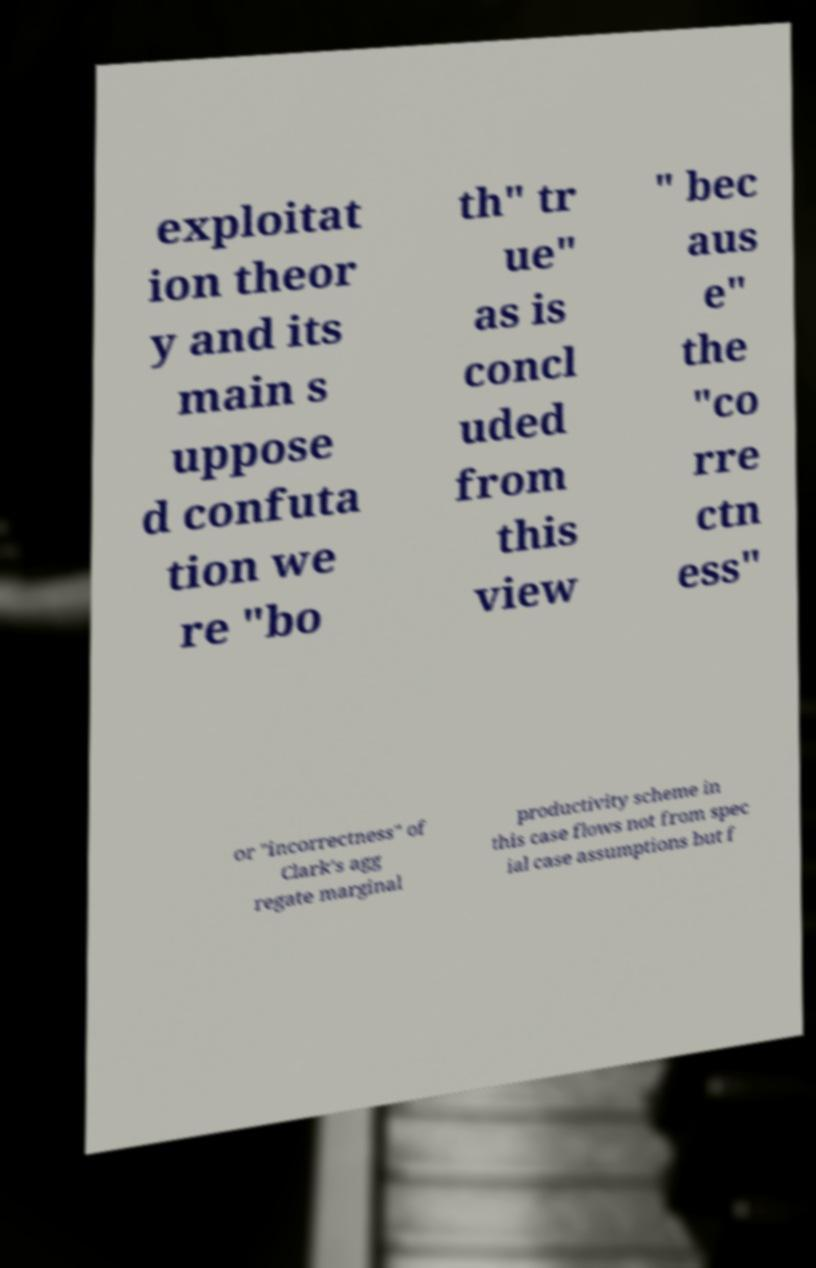Please identify and transcribe the text found in this image. exploitat ion theor y and its main s uppose d confuta tion we re "bo th" tr ue" as is concl uded from this view " bec aus e" the "co rre ctn ess" or "incorrectness" of Clark's agg regate marginal productivity scheme in this case flows not from spec ial case assumptions but f 